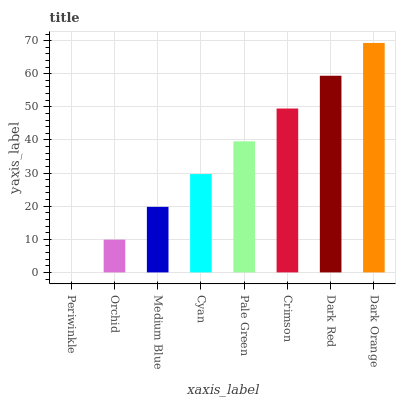Is Periwinkle the minimum?
Answer yes or no. Yes. Is Dark Orange the maximum?
Answer yes or no. Yes. Is Orchid the minimum?
Answer yes or no. No. Is Orchid the maximum?
Answer yes or no. No. Is Orchid greater than Periwinkle?
Answer yes or no. Yes. Is Periwinkle less than Orchid?
Answer yes or no. Yes. Is Periwinkle greater than Orchid?
Answer yes or no. No. Is Orchid less than Periwinkle?
Answer yes or no. No. Is Pale Green the high median?
Answer yes or no. Yes. Is Cyan the low median?
Answer yes or no. Yes. Is Dark Orange the high median?
Answer yes or no. No. Is Orchid the low median?
Answer yes or no. No. 